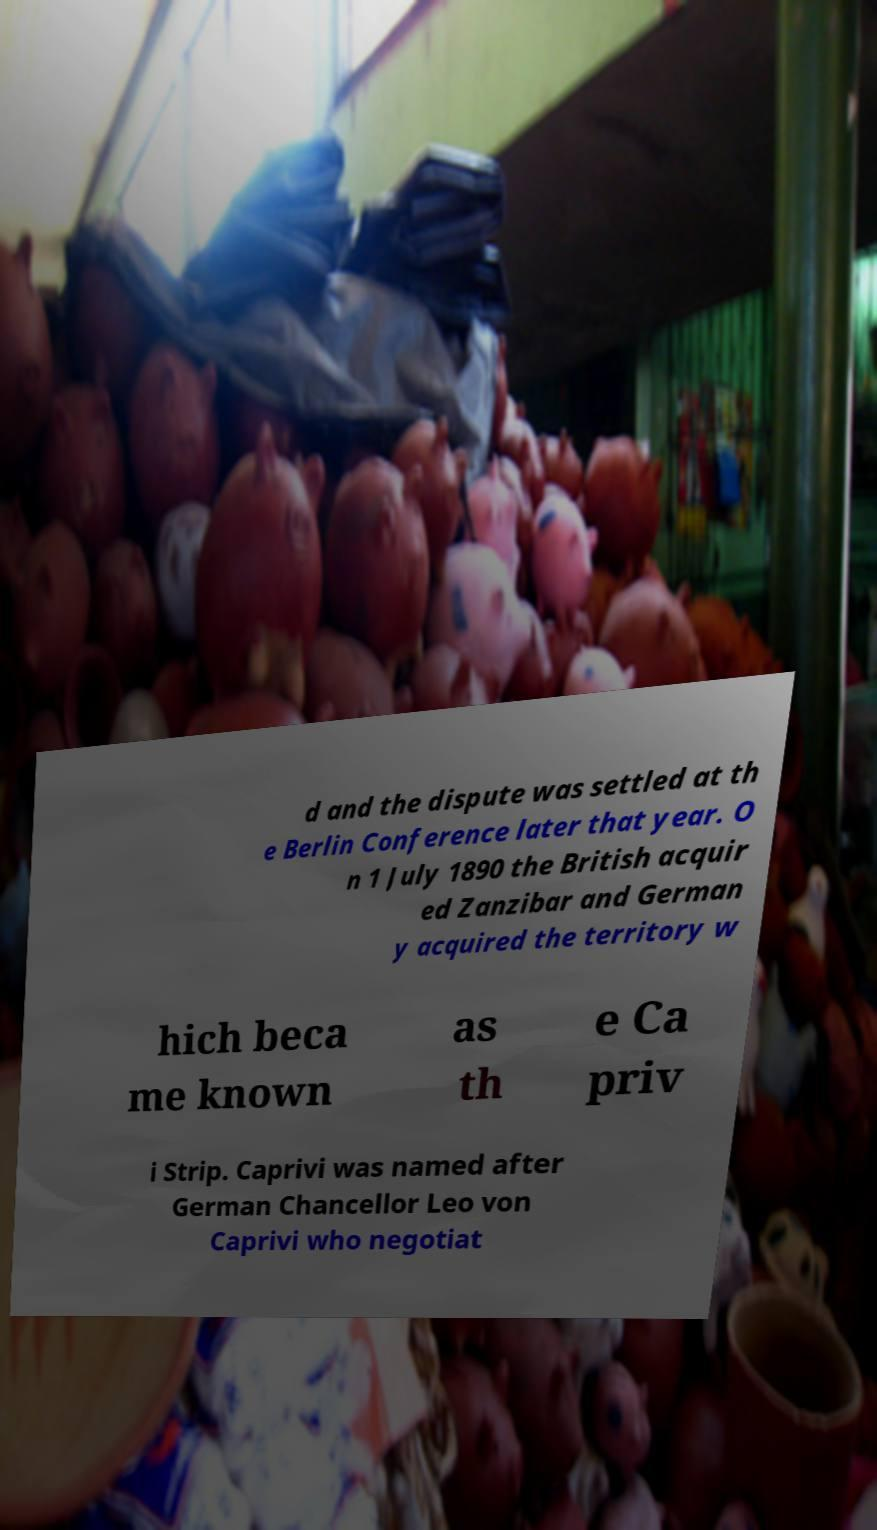For documentation purposes, I need the text within this image transcribed. Could you provide that? d and the dispute was settled at th e Berlin Conference later that year. O n 1 July 1890 the British acquir ed Zanzibar and German y acquired the territory w hich beca me known as th e Ca priv i Strip. Caprivi was named after German Chancellor Leo von Caprivi who negotiat 